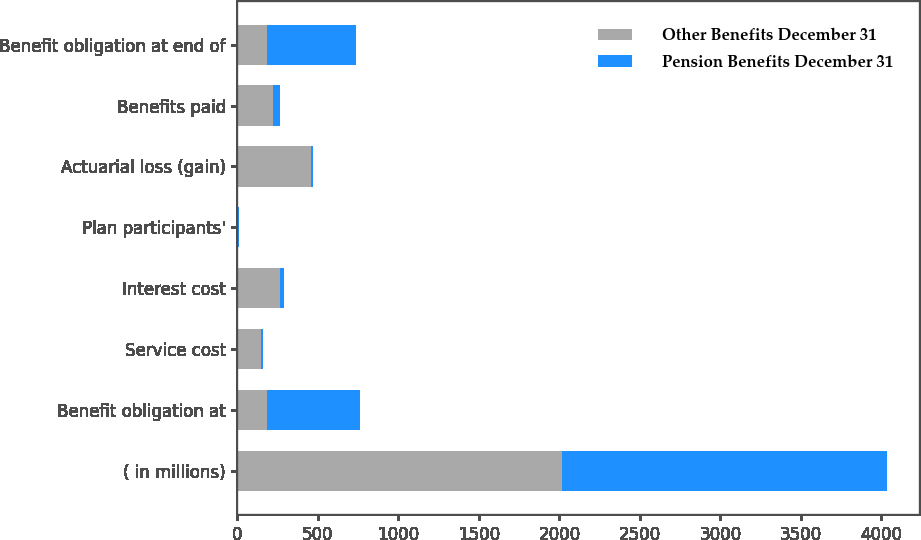Convert chart to OTSL. <chart><loc_0><loc_0><loc_500><loc_500><stacked_bar_chart><ecel><fcel>( in millions)<fcel>Benefit obligation at<fcel>Service cost<fcel>Interest cost<fcel>Plan participants'<fcel>Actuarial loss (gain)<fcel>Benefits paid<fcel>Benefit obligation at end of<nl><fcel>Other Benefits December 31<fcel>2017<fcel>182.5<fcel>146<fcel>266<fcel>4<fcel>457<fcel>219<fcel>182.5<nl><fcel>Pension Benefits December 31<fcel>2017<fcel>578<fcel>10<fcel>24<fcel>8<fcel>15<fcel>42<fcel>553<nl></chart> 